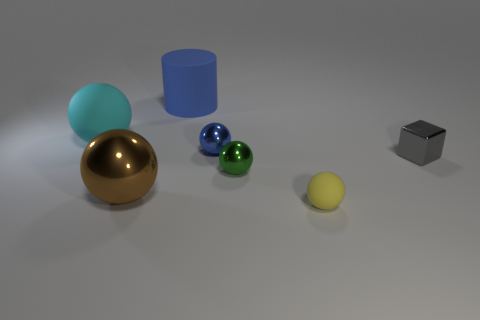Subtract all small green shiny balls. How many balls are left? 4 Subtract 1 balls. How many balls are left? 4 Subtract all green spheres. How many spheres are left? 4 Subtract all red balls. Subtract all red cylinders. How many balls are left? 5 Add 2 tiny green balls. How many objects exist? 9 Subtract all balls. How many objects are left? 2 Add 6 small blue shiny things. How many small blue shiny things exist? 7 Subtract 0 brown cubes. How many objects are left? 7 Subtract all big blue metal things. Subtract all yellow balls. How many objects are left? 6 Add 5 cyan rubber things. How many cyan rubber things are left? 6 